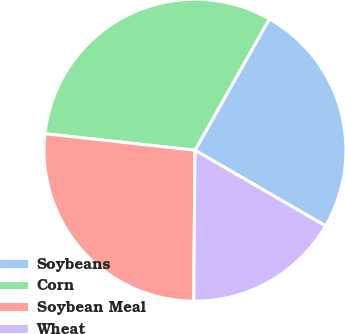<chart> <loc_0><loc_0><loc_500><loc_500><pie_chart><fcel>Soybeans<fcel>Corn<fcel>Soybean Meal<fcel>Wheat<nl><fcel>25.16%<fcel>31.45%<fcel>26.62%<fcel>16.77%<nl></chart> 